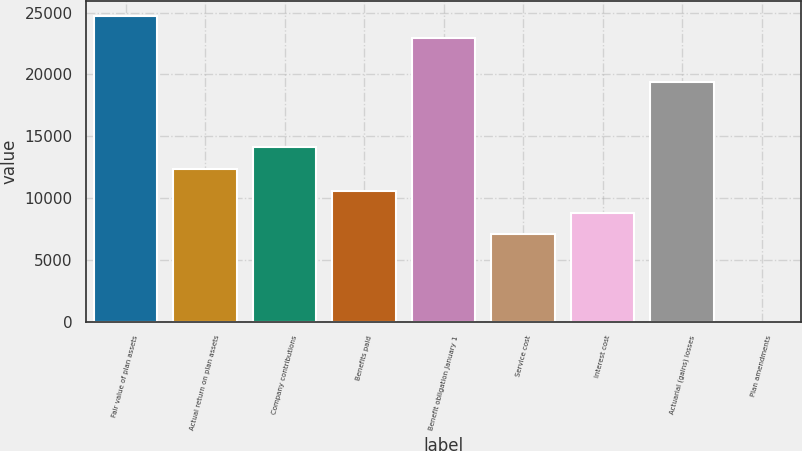Convert chart. <chart><loc_0><loc_0><loc_500><loc_500><bar_chart><fcel>Fair value of plan assets<fcel>Actual return on plan assets<fcel>Company contributions<fcel>Benefits paid<fcel>Benefit obligation January 1<fcel>Service cost<fcel>Interest cost<fcel>Actuarial (gains) losses<fcel>Plan amendments<nl><fcel>24703.6<fcel>12352.8<fcel>14117.2<fcel>10588.4<fcel>22939.2<fcel>7059.6<fcel>8824<fcel>19410.4<fcel>2<nl></chart> 